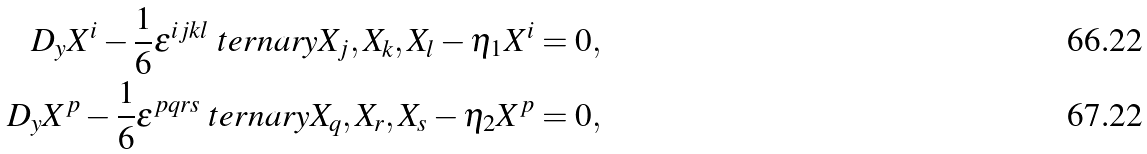Convert formula to latex. <formula><loc_0><loc_0><loc_500><loc_500>D _ { y } X ^ { i } - \frac { 1 } { 6 } \epsilon ^ { i j k l } \ t e r n a r y { X _ { j } , X _ { k } , X _ { l } } - \eta _ { 1 } X ^ { i } = 0 , \\ D _ { y } X ^ { p } - \frac { 1 } { 6 } \epsilon ^ { p q r s } \ t e r n a r y { X _ { q } , X _ { r } , X _ { s } } - \eta _ { 2 } X ^ { p } = 0 ,</formula> 